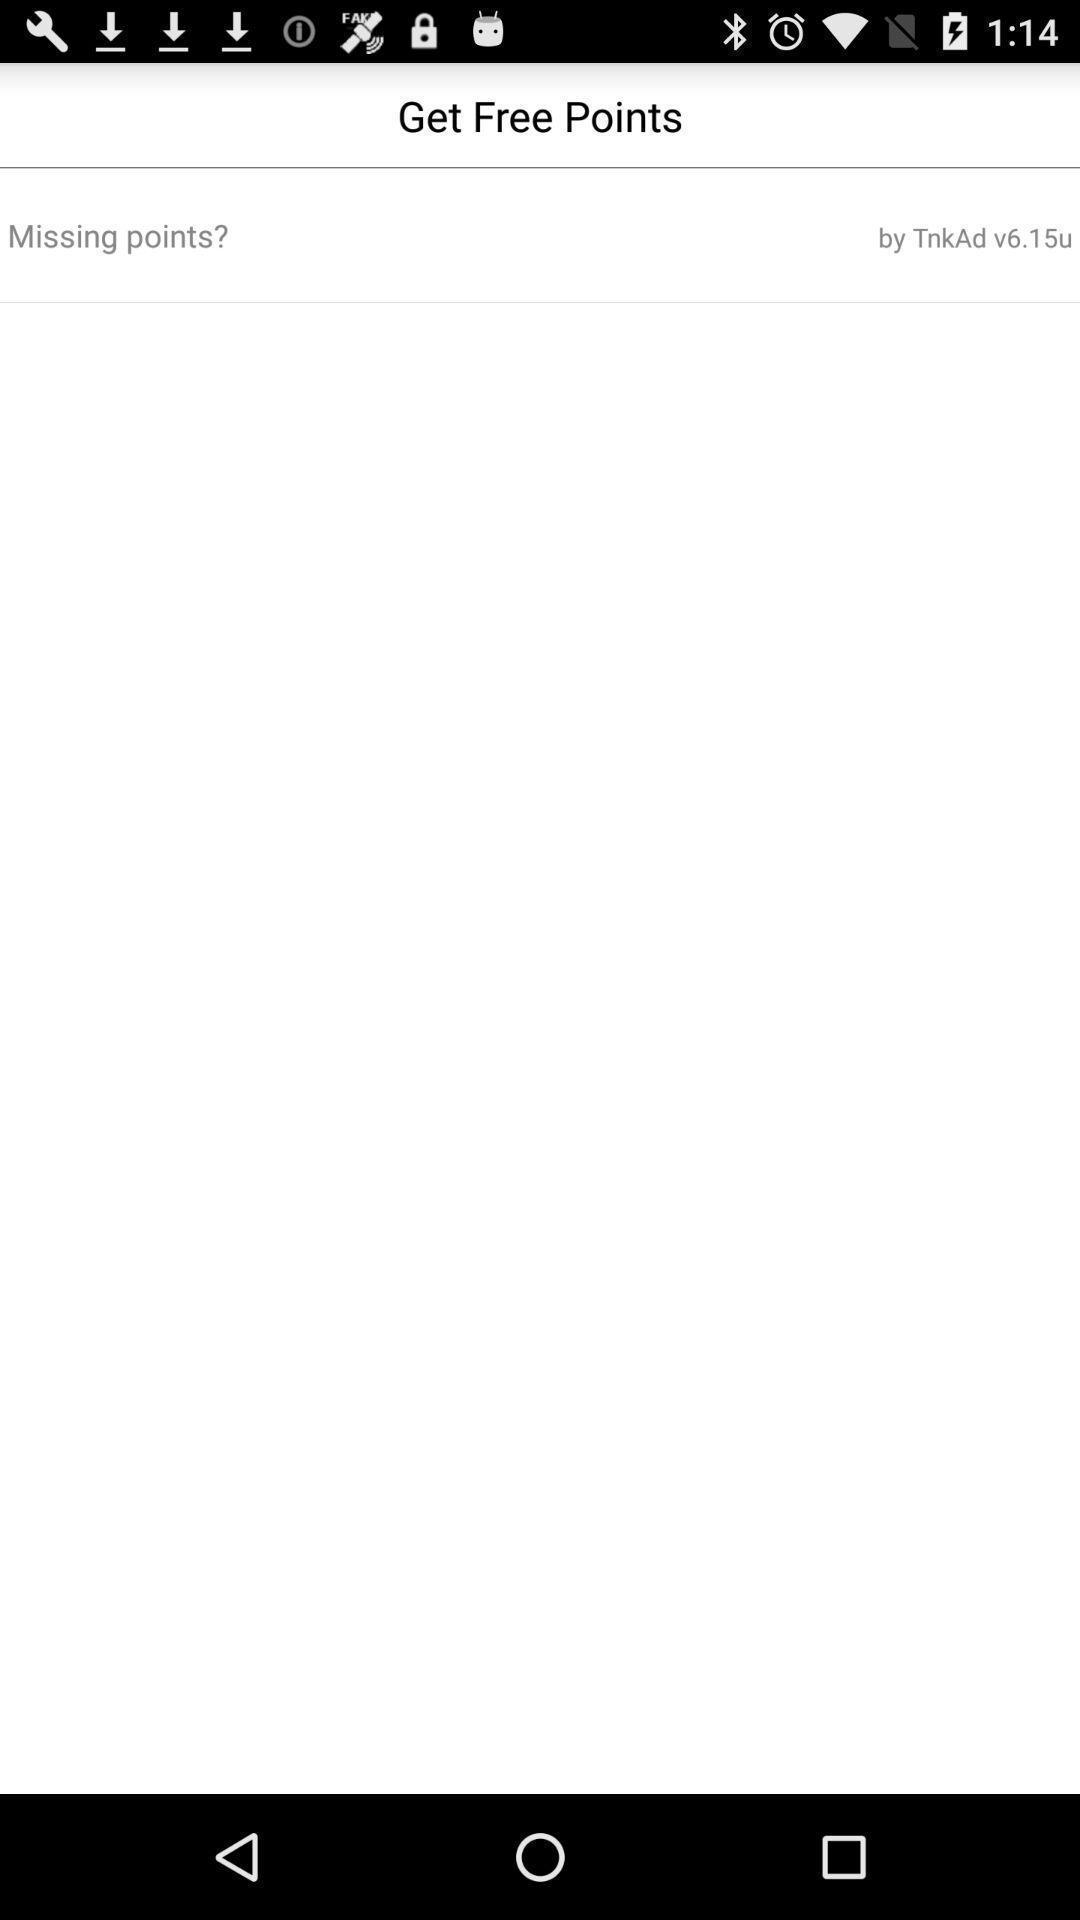Provide a description of this screenshot. Page showing free points on an app. 